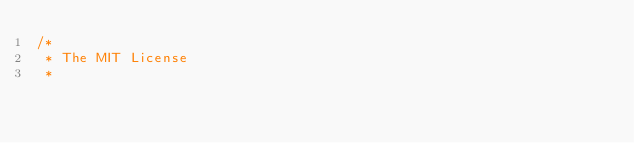Convert code to text. <code><loc_0><loc_0><loc_500><loc_500><_Java_>/*
 * The MIT License
 * </code> 